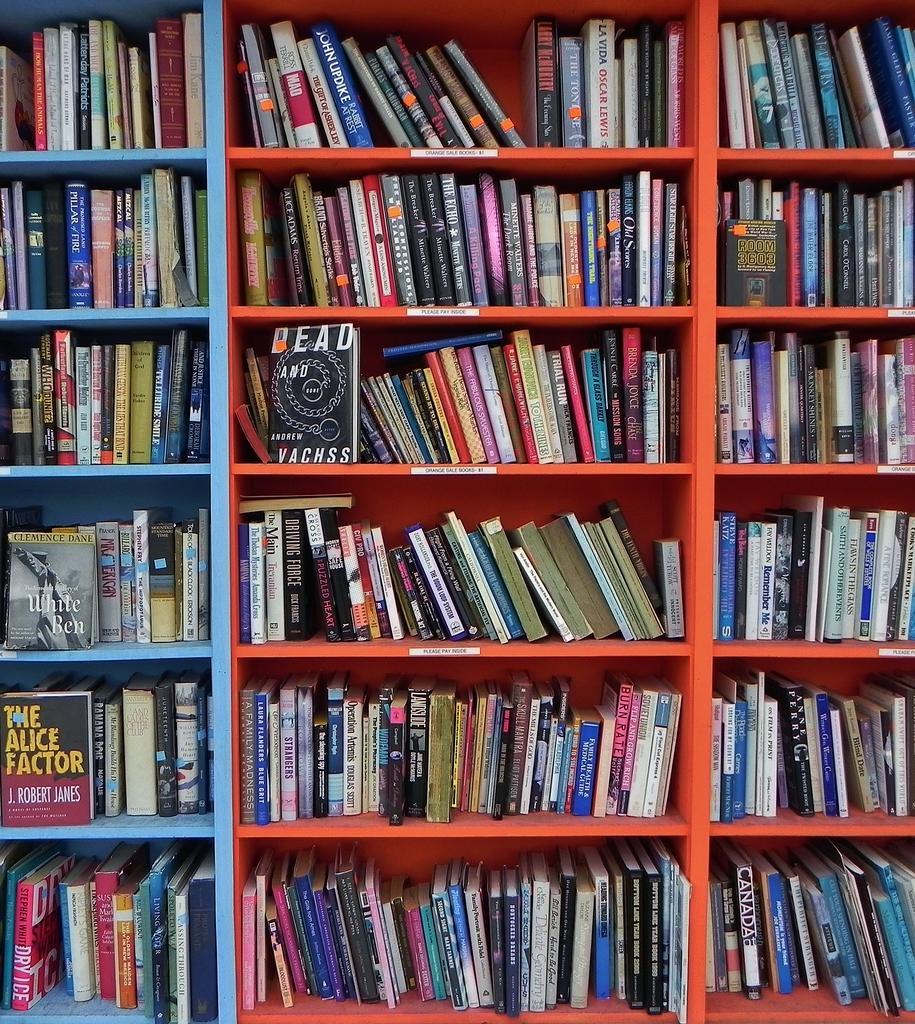In one or two sentences, can you explain what this image depicts? In the image we can see a bookshelf. 